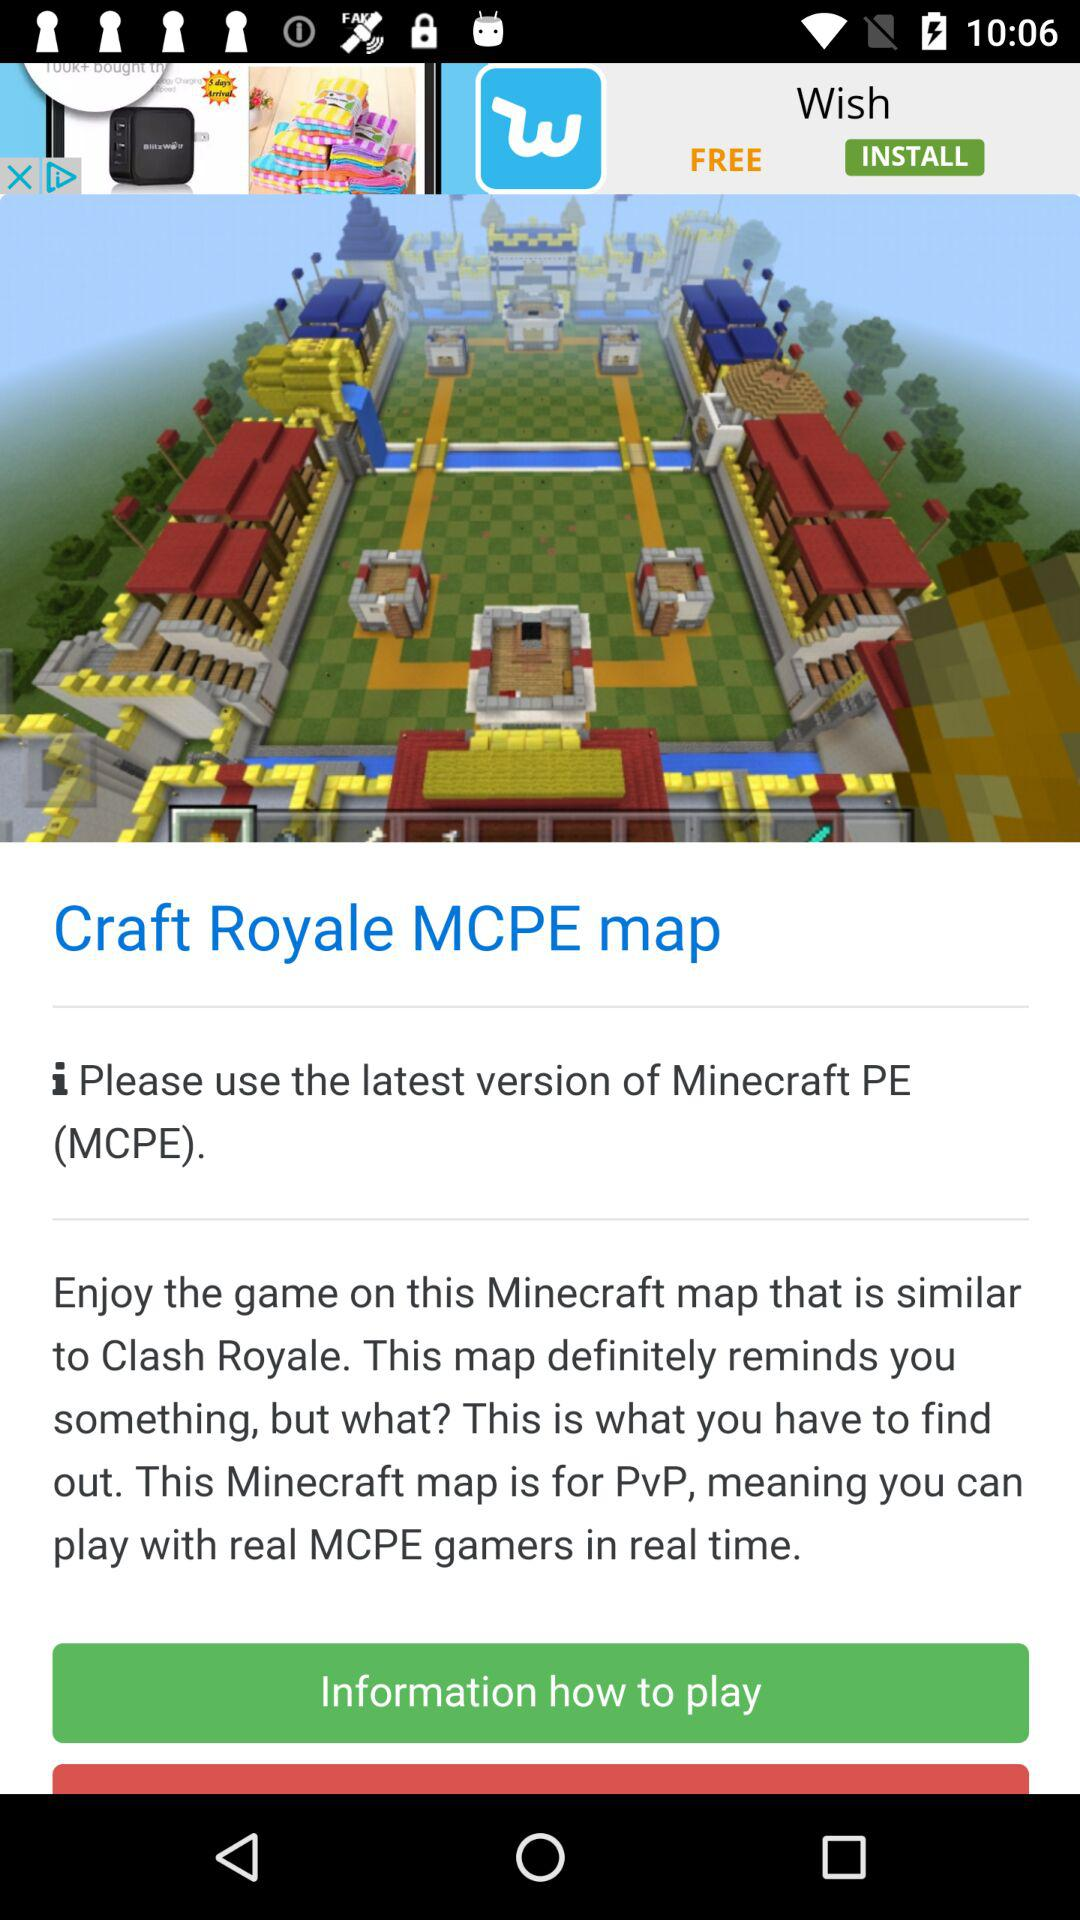What is the full form of MCPE? The full form of MCPE is "Minecraft PE". 